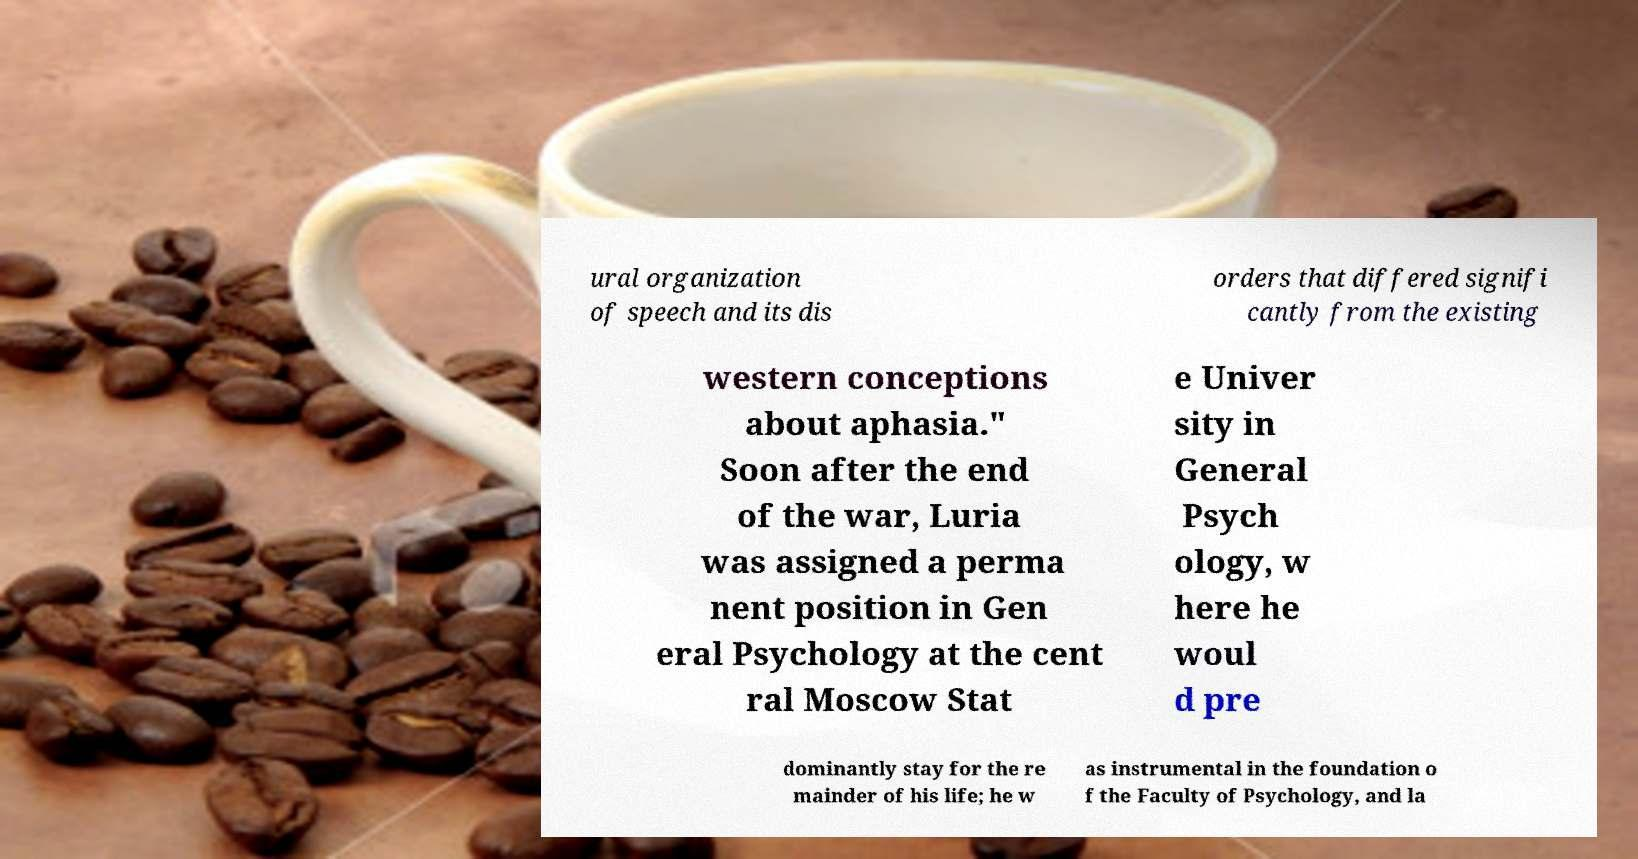For documentation purposes, I need the text within this image transcribed. Could you provide that? ural organization of speech and its dis orders that differed signifi cantly from the existing western conceptions about aphasia." Soon after the end of the war, Luria was assigned a perma nent position in Gen eral Psychology at the cent ral Moscow Stat e Univer sity in General Psych ology, w here he woul d pre dominantly stay for the re mainder of his life; he w as instrumental in the foundation o f the Faculty of Psychology, and la 